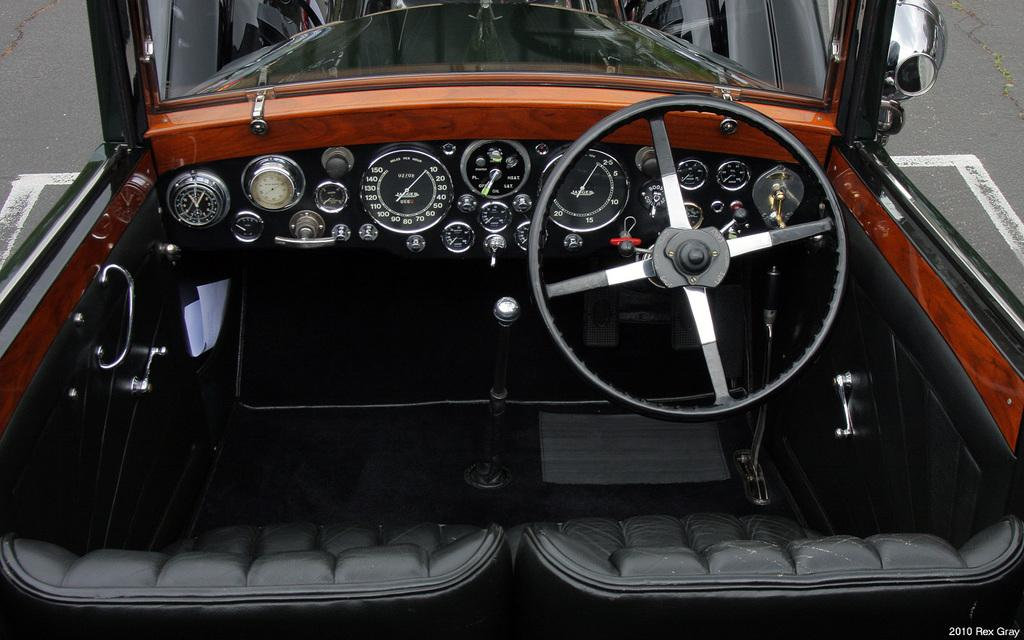What type of setting is depicted in the image? The image shows the interior of a vehicle. Can you describe what is visible outside the vehicle? The ground is visible in the image. What type of shock can be seen affecting the passengers in the image? There is no shock or any indication of passengers in the image; it only shows the interior of a vehicle and the ground outside. 